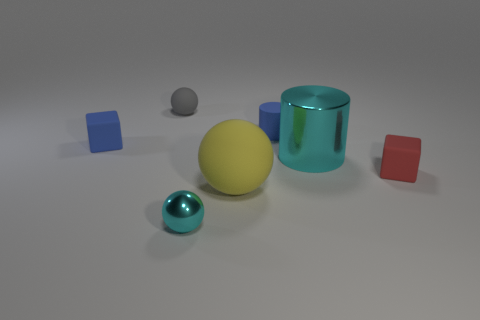The blue thing behind the blue object that is left of the cyan shiny thing in front of the red rubber cube is what shape?
Your response must be concise. Cylinder. The matte sphere that is the same size as the blue block is what color?
Offer a terse response. Gray. How many tiny cyan shiny objects are the same shape as the big yellow thing?
Ensure brevity in your answer.  1. There is a red matte thing; is it the same size as the blue thing right of the blue block?
Your answer should be very brief. Yes. There is a tiny blue rubber object right of the tiny sphere behind the small shiny ball; what is its shape?
Offer a terse response. Cylinder. Is the number of blue matte objects that are in front of the red cube less than the number of big red metallic cylinders?
Offer a terse response. No. There is a tiny object that is the same color as the matte cylinder; what shape is it?
Your response must be concise. Cube. How many red objects are the same size as the yellow object?
Ensure brevity in your answer.  0. What is the shape of the big object on the right side of the tiny blue matte cylinder?
Your answer should be compact. Cylinder. Are there fewer tiny purple shiny cubes than large metal cylinders?
Your answer should be very brief. Yes. 